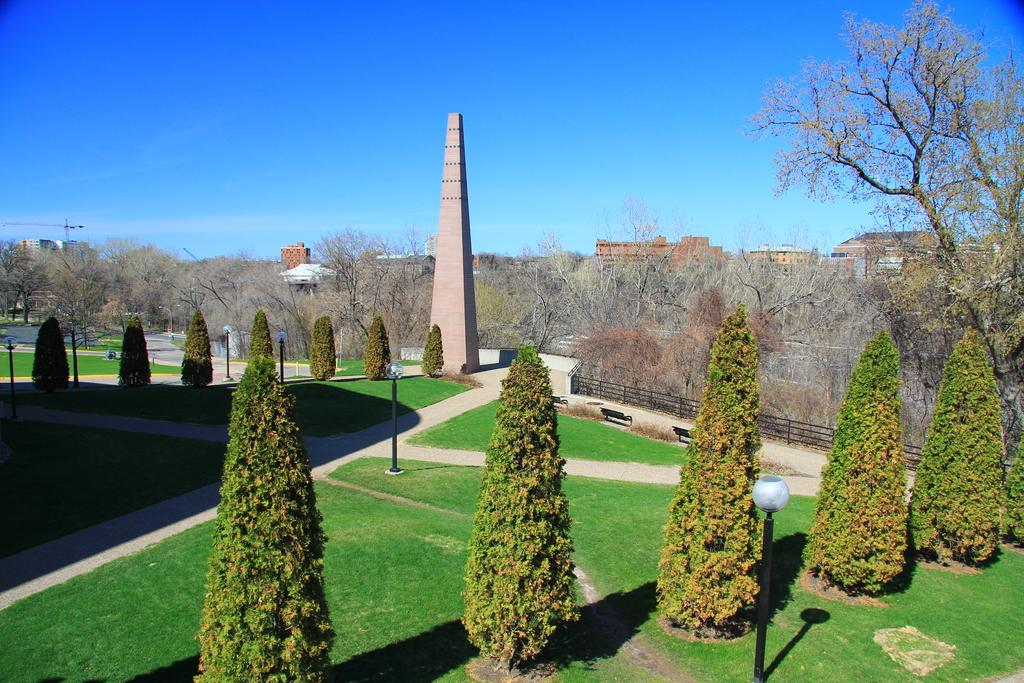What type of vegetation can be seen in the image? There are trees in the image. What structures are present on the ground in the image? There are poles on the ground in the image. What can be seen in the background of the image? There is a tower, buildings, and the sky visible in the background of the image. What language is being spoken by the tree branches in the image? There are no tree branches speaking any language in the image, as tree branches do not have the ability to speak. 